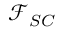<formula> <loc_0><loc_0><loc_500><loc_500>\mathcal { F } _ { S C }</formula> 